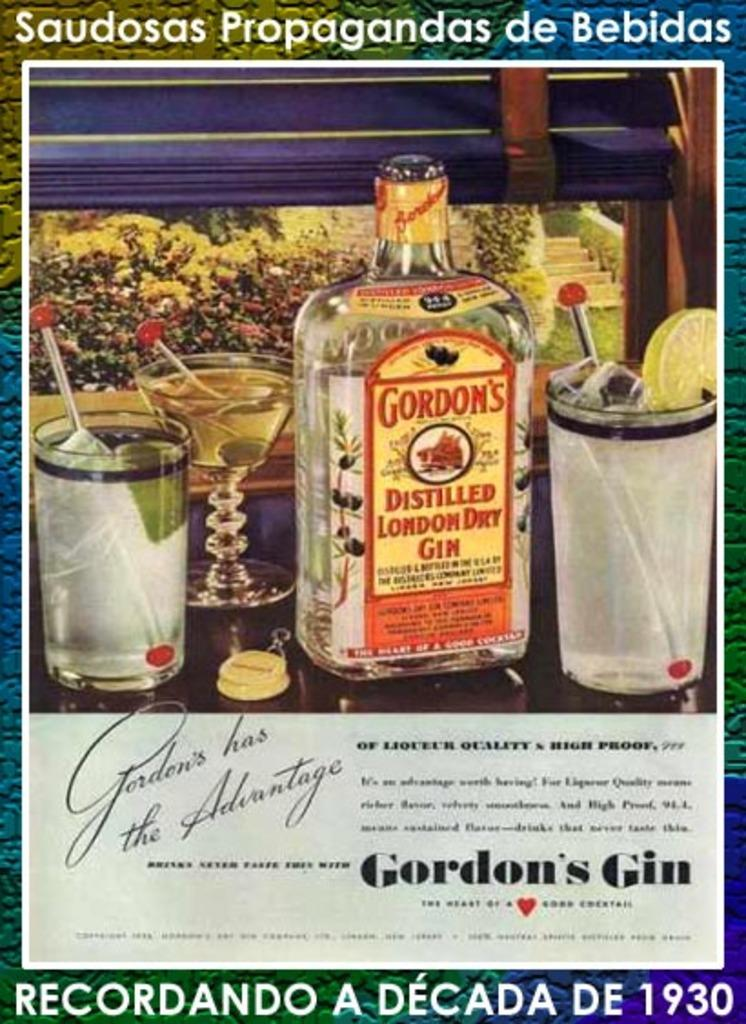<image>
Relay a brief, clear account of the picture shown. An advertisement for Gordon's gin shows three different cocktails. 